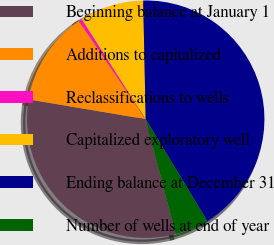Convert chart. <chart><loc_0><loc_0><loc_500><loc_500><pie_chart><fcel>Beginning balance at January 1<fcel>Additions to capitalized<fcel>Reclassifications to wells<fcel>Capitalized exploratory well<fcel>Ending balance at December 31<fcel>Number of wells at end of year<nl><fcel>31.73%<fcel>12.83%<fcel>0.46%<fcel>8.71%<fcel>41.68%<fcel>4.59%<nl></chart> 